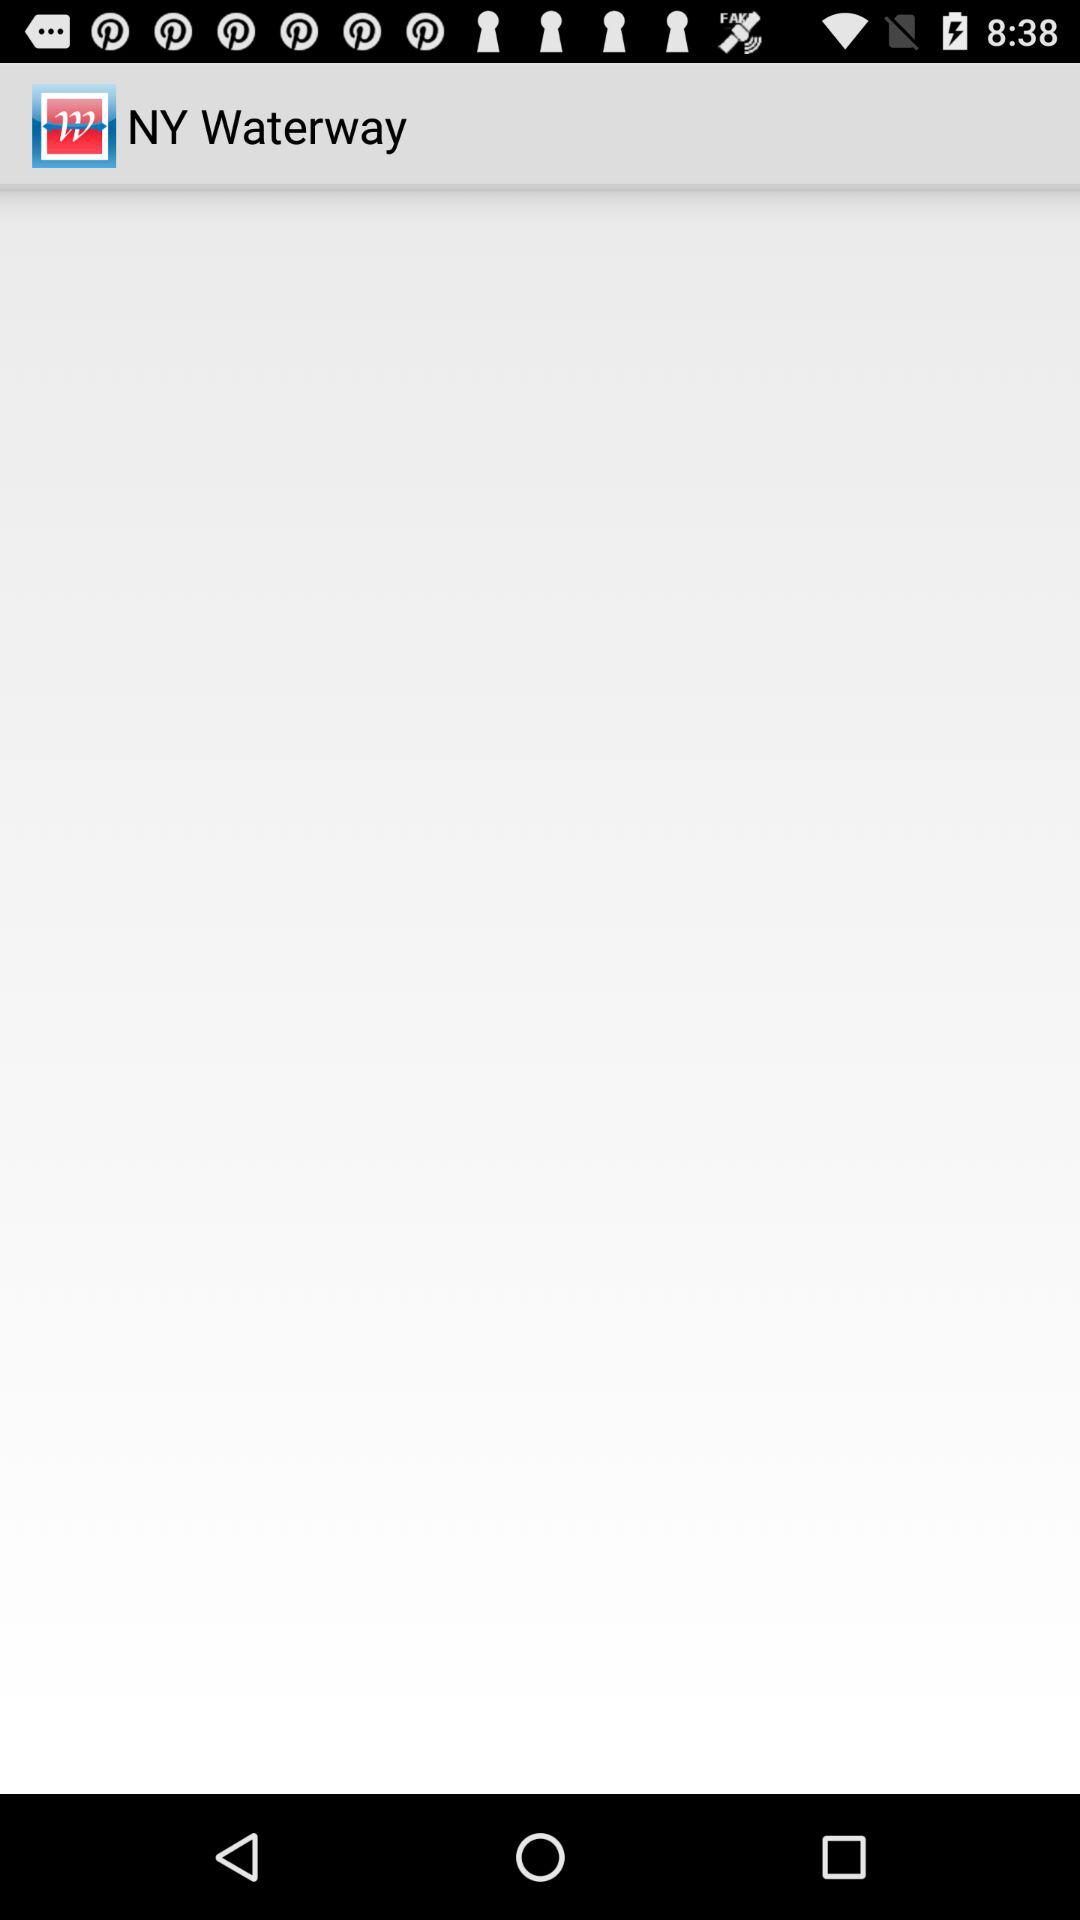Who developed the "NY Waterway" app?
When the provided information is insufficient, respond with <no answer>. <no answer> 